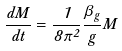<formula> <loc_0><loc_0><loc_500><loc_500>\frac { d M } { d t } = \frac { 1 } { 8 \pi ^ { 2 } } \frac { \beta _ { g } } { g } M</formula> 